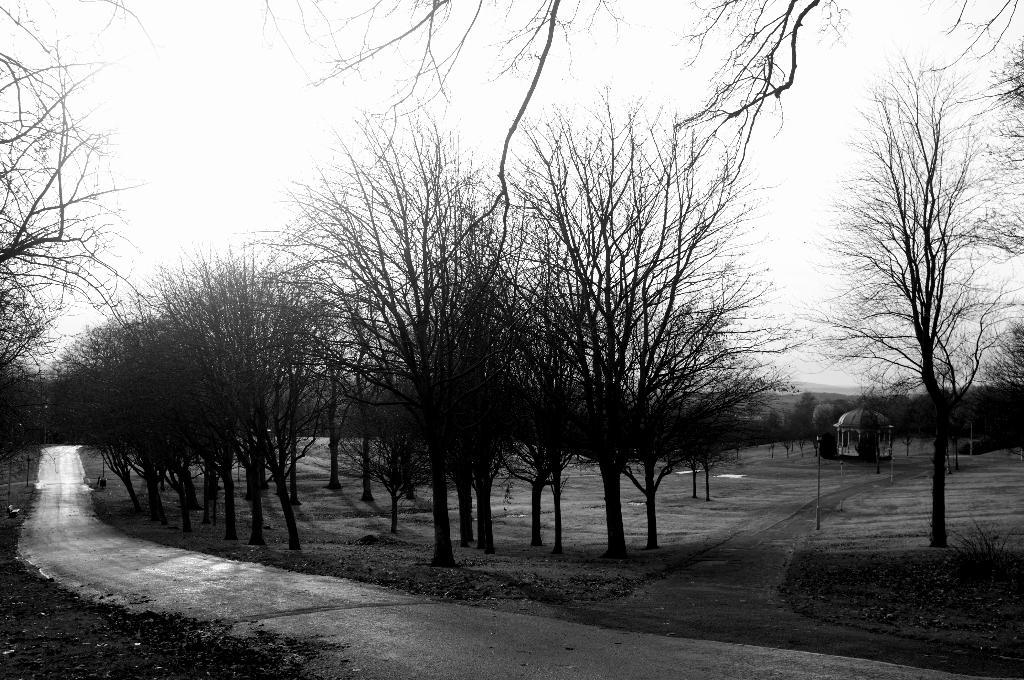What type of natural elements can be seen in the image? There are trees in the image. What part of the natural environment is visible in the image? The sky is visible in the image. What is the surface on which the trees and sky are situated? The ground is present in the image. What type of structure can be seen in the image? There is a tomb-like structure in the image. How many goldfish are swimming in the liquid in the image? There is no liquid or goldfish present in the image. 